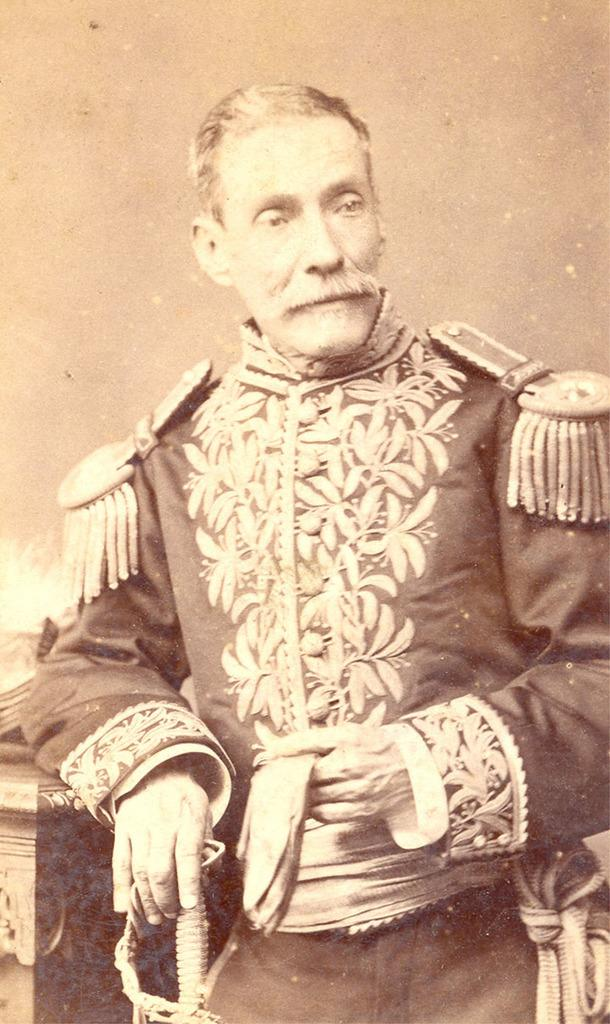What is the color scheme of the image? The image is black and white. What can be seen in the image? There is a man standing in the image. What is the man wearing? The man is wearing a uniform. What is the man holding in the image? The man is holding an object in the image. What type of lock is the man using to secure the list in the image? There is no lock or list present in the image. What type of servant is the man in the image? The image does not provide information about the man's role or occupation, so it cannot be determined if he is a servant. 